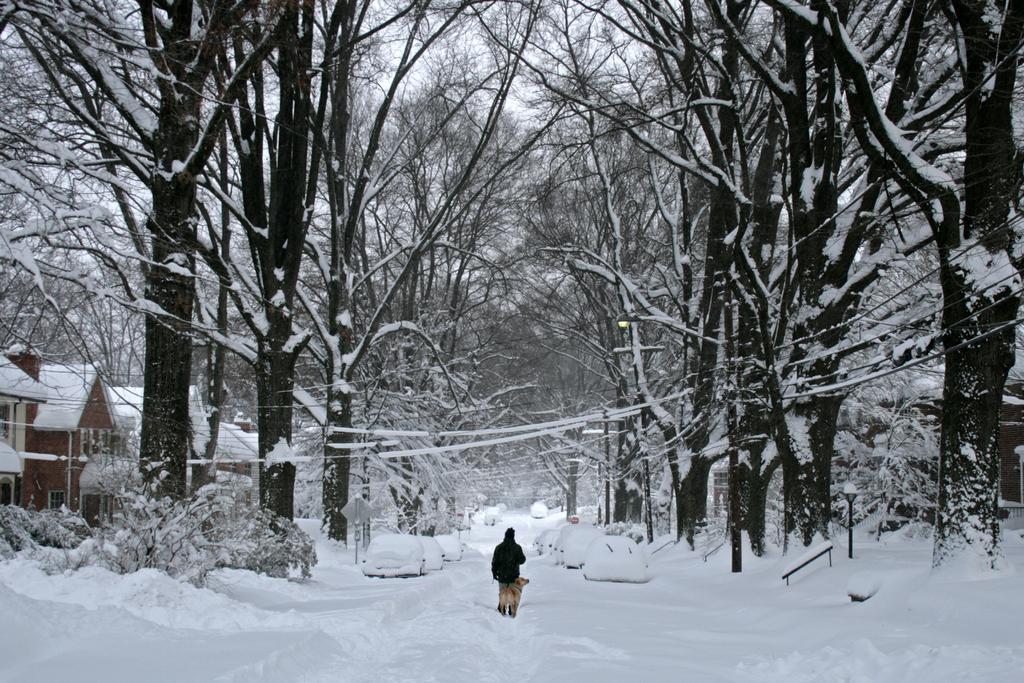Can you describe this image briefly? In this picture we can see trees, houses, sign Board, cars full of snow and a person walking in the snow along with him a dog is there. 